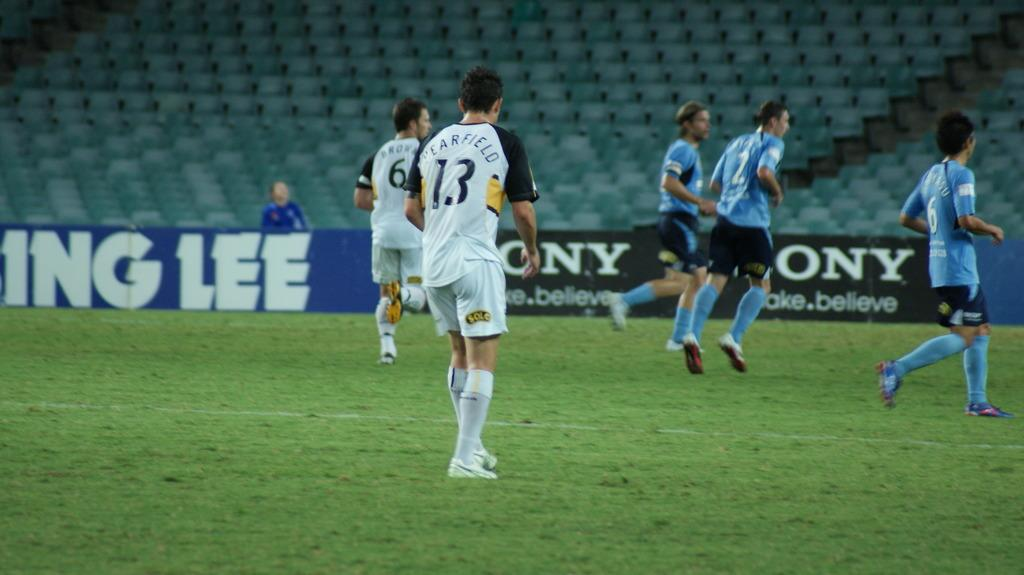What is happening in the image? There are persons standing on the ground in the image. What else can be seen in the image? There is an advertisement in the image. What does the caption on the advertisement say in the image? There is no caption present on the advertisement in the image. How many mouths can be seen in the image? There are no mouths visible in the image. 